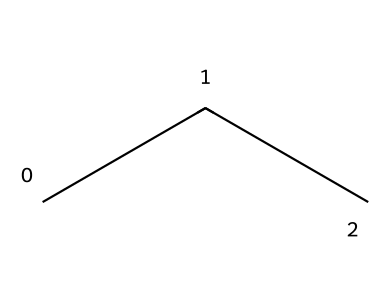What is the name of this chemical? The SMILES representation "CCC" indicates a three-carbon chain with single bonds, which is known as propane.
Answer: propane How many hydrogen atoms are in propane? Propane (C3H8) adheres to the general formula for alkanes, CnH2n+2, where n is 3 for propane, resulting in 2(3)+2 = 8 hydrogen atoms.
Answer: 8 What is the bond angle in propane? In propane, the central carbon atoms are tetrahedral due to sp3 hybridization, leading to a bond angle of approximately 109.5 degrees.
Answer: 109.5 degrees What type of bonds are present in propane? Propane contains only single bonds (sigma bonds) between carbon and hydrogen atoms.
Answer: sigma bonds What is the molecular shape of propane? The geometry around each carbon atom in propane is tetrahedral, contributing to its overall zig-zag shape.
Answer: zig-zag What is the bond length between carbon atoms in propane? The typical carbon-carbon bond length in aliphatic compounds like propane is about 1.54 angstroms.
Answer: 1.54 angstroms How does the structure of propane influence its physical properties? The straight-chain structure of propane leads to relatively low boiling and melting points compared to larger alkanes, a result of weaker van der Waals forces.
Answer: low boiling point 